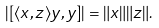<formula> <loc_0><loc_0><loc_500><loc_500>\left | [ \langle x , z \rangle y , y ] \right | = \| x \| \| z \| .</formula> 